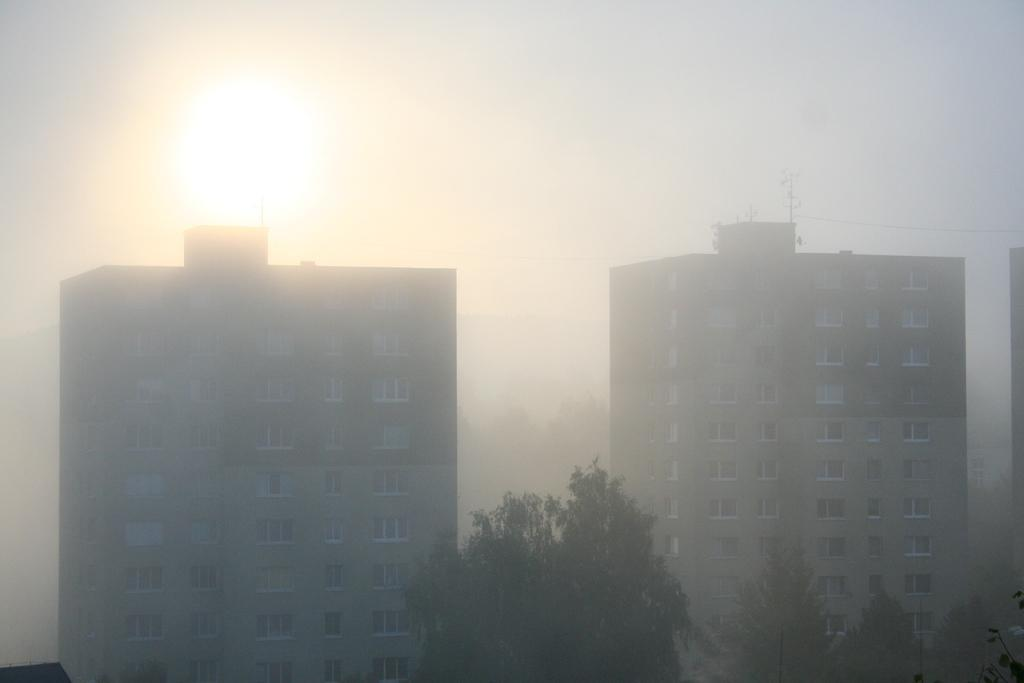How many buildings with windows can be seen in the image? There are two buildings with windows in the image. What is located in the center of the image? There is a tree in the center of the image. What is the weather like in the image? The sky is foggy in the image, which suggests a misty or hazy condition. Can the sun be seen in the image? Yes, the sun is visible in the sky. What is the title of the book that the tree is holding in the image? There is no book present in the image, and the tree is not holding anything. 